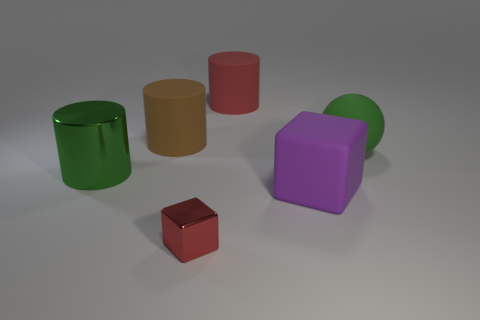What color is the other large matte thing that is the same shape as the big brown matte object?
Your answer should be compact. Red. There is a big ball that is the same material as the big purple cube; what color is it?
Make the answer very short. Green. How many brown rubber things have the same size as the ball?
Offer a terse response. 1. What material is the tiny object?
Ensure brevity in your answer.  Metal. Are there more large red matte objects than rubber cylinders?
Ensure brevity in your answer.  No. Does the purple thing have the same shape as the brown object?
Offer a terse response. No. Is there anything else that is the same shape as the tiny thing?
Provide a succinct answer. Yes. Do the matte object to the right of the big purple cube and the cube that is in front of the large cube have the same color?
Provide a succinct answer. No. Is the number of large green metal objects that are behind the large brown matte thing less than the number of small red cubes that are left of the large green metal object?
Offer a very short reply. No. What is the shape of the green thing in front of the large sphere?
Ensure brevity in your answer.  Cylinder. 